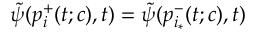Convert formula to latex. <formula><loc_0><loc_0><loc_500><loc_500>\tilde { \psi } ( p _ { i } ^ { + } ( t ; c ) , t ) = \tilde { \psi } ( p _ { i _ { * } } ^ { - } ( t ; c ) , t )</formula> 